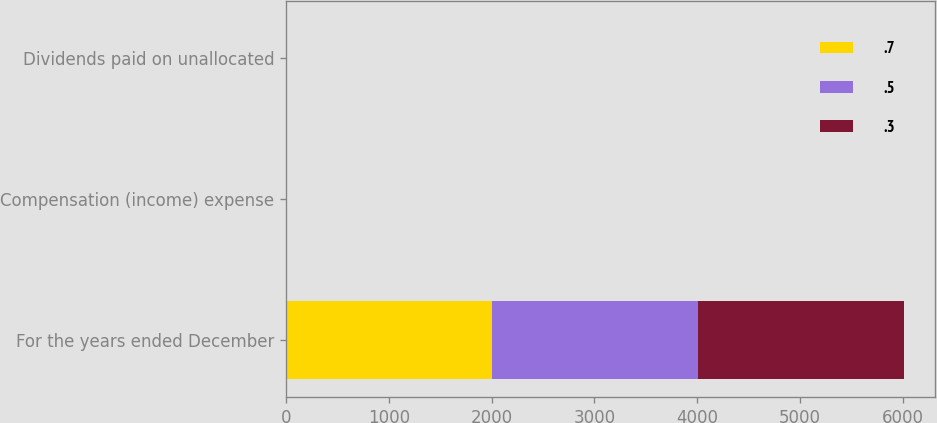Convert chart. <chart><loc_0><loc_0><loc_500><loc_500><stacked_bar_chart><ecel><fcel>For the years ended December<fcel>Compensation (income) expense<fcel>Dividends paid on unallocated<nl><fcel>0.7<fcel>2006<fcel>0.3<fcel>0.3<nl><fcel>0.5<fcel>2005<fcel>0.4<fcel>0.5<nl><fcel>0.3<fcel>2004<fcel>0.1<fcel>0.7<nl></chart> 